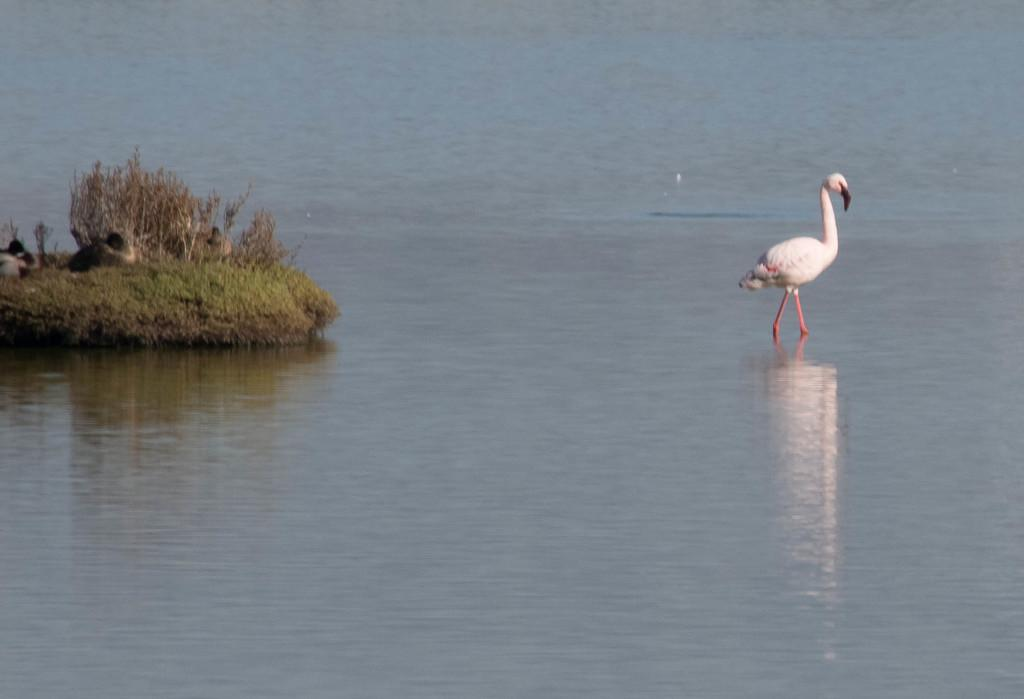What type of animal is in the water in the image? There is a flamingo in the water in the image. What type of vegetation is on the left side of the image? There is grass on the ground on the left side of the image. What other animals can be seen in the image? There are ducks in the image. What type of riddle is the flamingo trying to solve in the image? There is no indication in the image that the flamingo is trying to solve a riddle. 